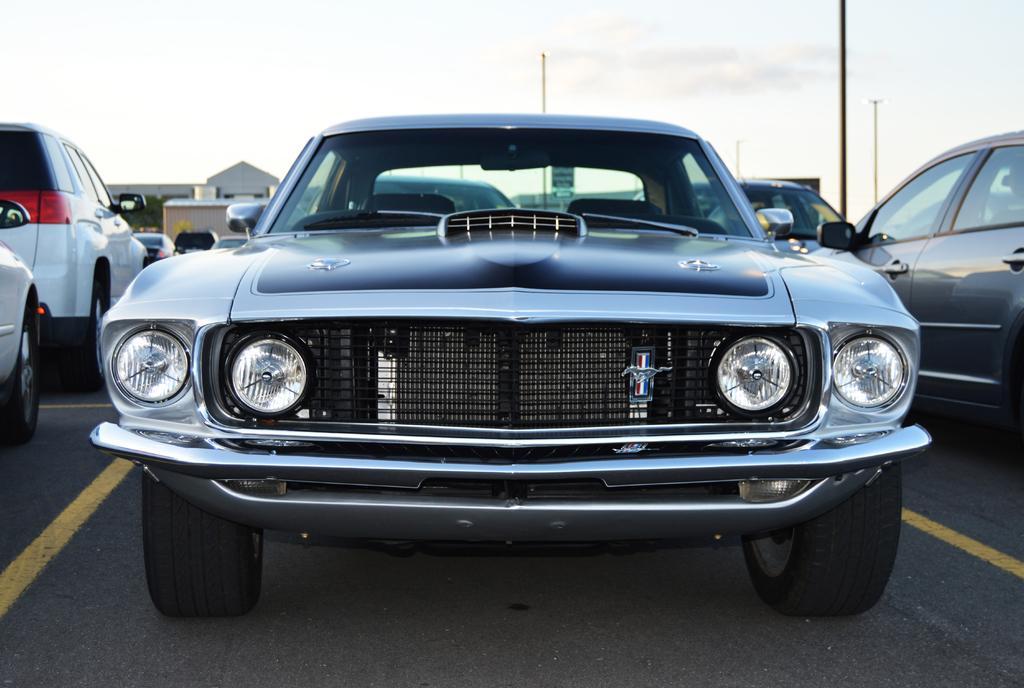How would you summarize this image in a sentence or two? In this image there is the sky towards the top of the image, there are poles, there are buildings, there is a board, there is text on the board, there are cars, there is road towards the bottom of the image. 